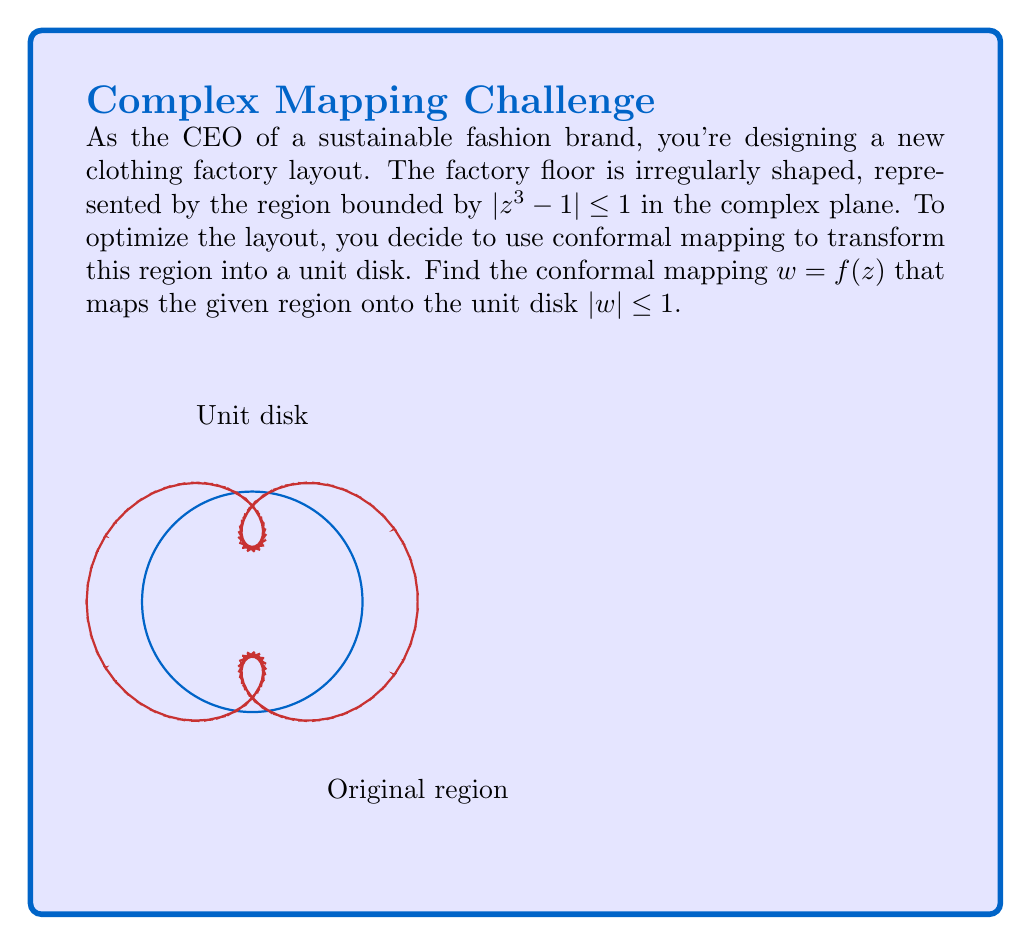Help me with this question. Let's approach this step-by-step:

1) The given region is bounded by $|z^3 - 1| \leq 1$. We need to map this onto the unit disk $|w| \leq 1$.

2) First, let's consider the boundary of the given region: $|z^3 - 1| = 1$

3) We can rewrite this as: $z^3 - 1 = e^{i\theta}$, where $\theta \in [0, 2\pi]$

4) Now, let's solve for $z^3$:
   $z^3 = 1 + e^{i\theta}$

5) To map this onto the unit circle, we need a function that takes $1 + e^{i\theta}$ to $e^{i\theta}$

6) The function $f(z) = \frac{z-1}{z}$ does exactly this:
   $f(1 + e^{i\theta}) = \frac{(1 + e^{i\theta}) - 1}{1 + e^{i\theta}} = \frac{e^{i\theta}}{1 + e^{i\theta}} = e^{i\theta}$

7) Therefore, our conformal mapping will be:
   $w = f(z^3) = \frac{z^3 - 1}{z^3}$

8) This function maps the boundary of our original region onto the unit circle, and the interior of the region onto the interior of the unit disk, as required.
Answer: $w = \frac{z^3 - 1}{z^3}$ 